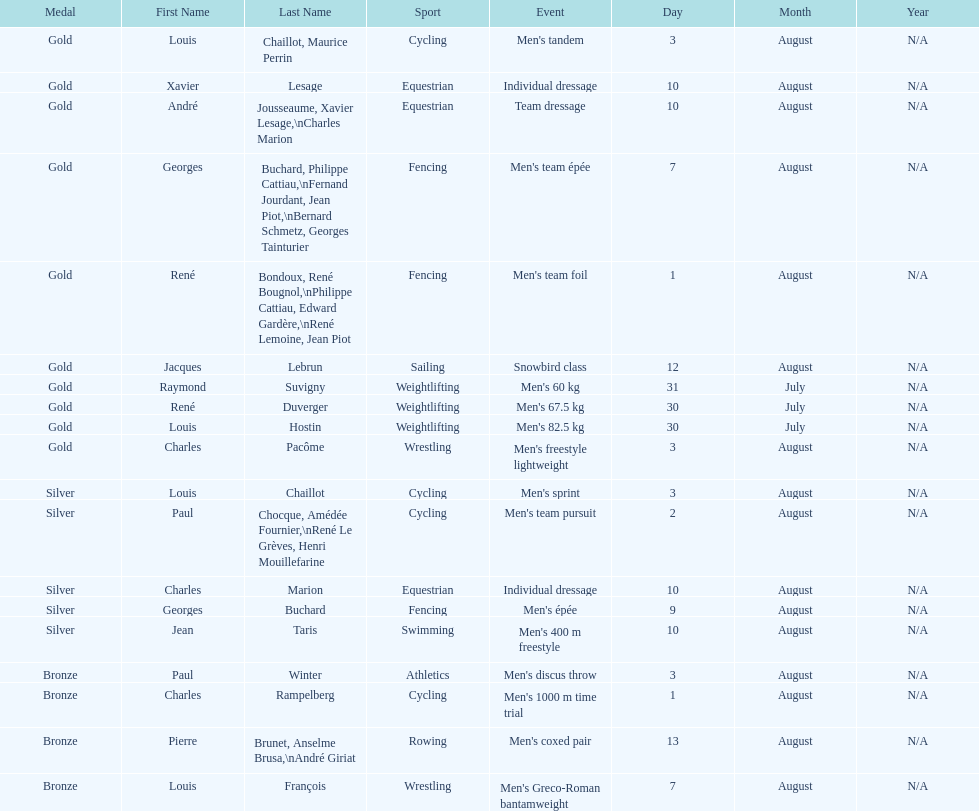What sport is listed first? Cycling. 